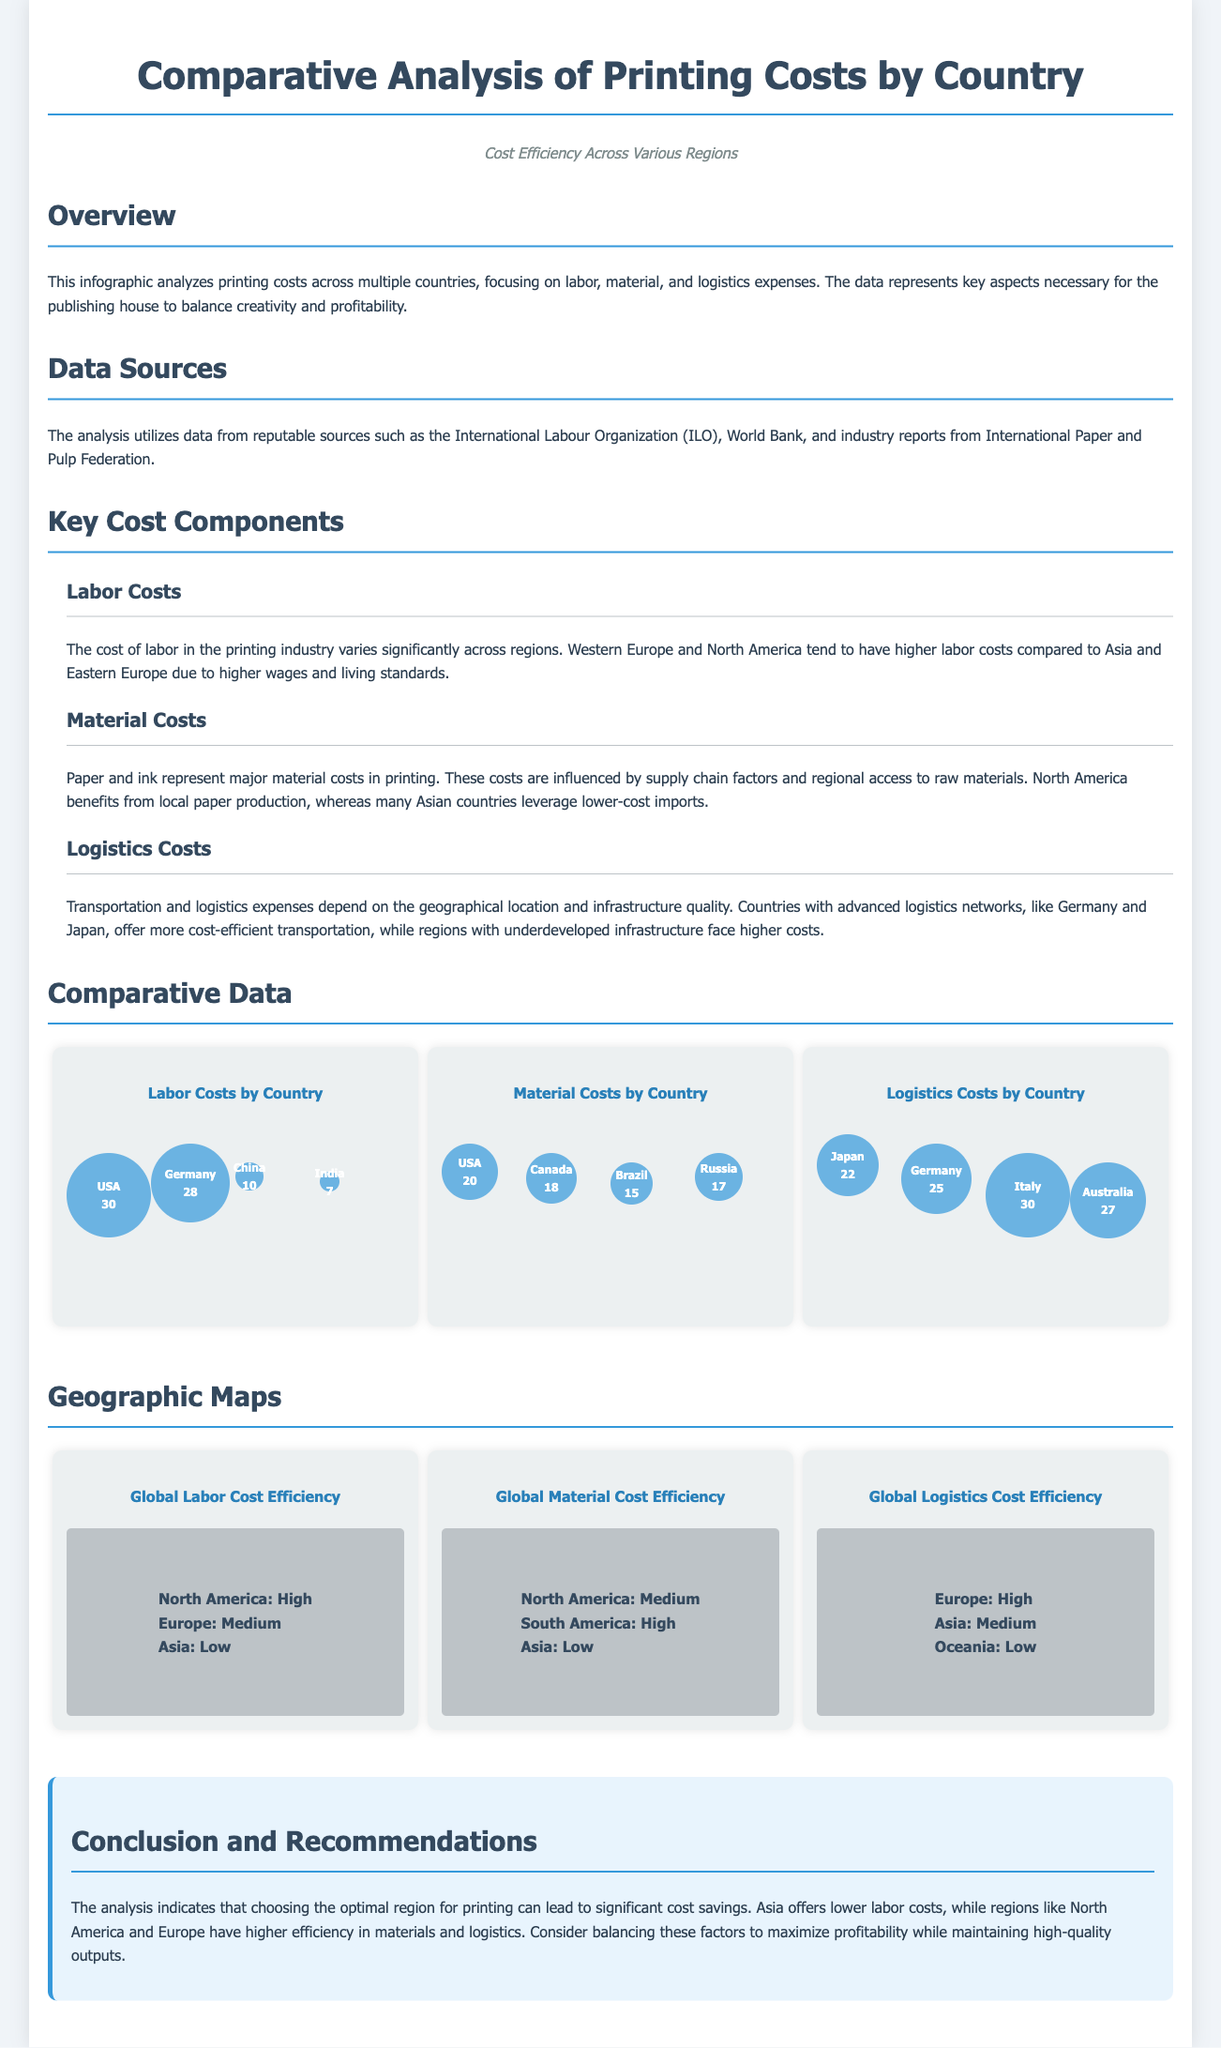What is the primary focus of the infographic? The infographic analyzes printing costs, emphasizing labor, material, and logistics expenses, essential for balancing creativity and profitability.
Answer: Printing costs Which organization provided data for this analysis? The analysis utilizes data from reputable sources, including the International Labour Organization (ILO), World Bank, and industry reports.
Answer: International Labour Organization What country has the highest labor cost? The labor costs by country indicate that the USA has the highest cost among those listed.
Answer: USA What is the efficiency level of logistics costs in Japan? According to the logistics data, Japan's efficiency level is rated at 9.
Answer: 9 Which region is noted for lower labor costs? The document states that Asia is known for lower labor costs in the printing industry.
Answer: Asia How many key cost components are highlighted in the infographic? The infographic identifies three key cost components related to printing costs.
Answer: Three What is the logistical efficiency level in Germany? The infographic mentions that Germany has a logistics efficiency level rated at 8.
Answer: 8 What is the primary benefit of North American paper production? North America benefits from local production of paper, which affects material costs positively.
Answer: Local paper production Which region exhibits high logistics cost efficiency according to the maps? The maps show that Europe exhibits high logistics cost efficiency.
Answer: Europe 